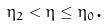<formula> <loc_0><loc_0><loc_500><loc_500>\eta _ { 2 } < \eta \leq \eta _ { 0 } \text {.}</formula> 